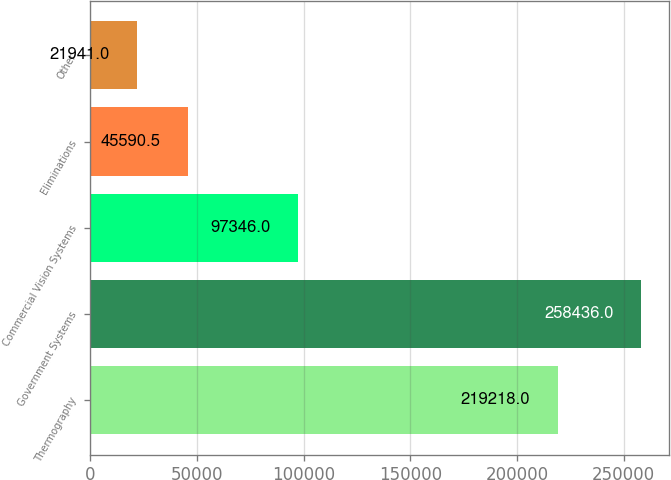Convert chart. <chart><loc_0><loc_0><loc_500><loc_500><bar_chart><fcel>Thermography<fcel>Government Systems<fcel>Commercial Vision Systems<fcel>Eliminations<fcel>Other<nl><fcel>219218<fcel>258436<fcel>97346<fcel>45590.5<fcel>21941<nl></chart> 